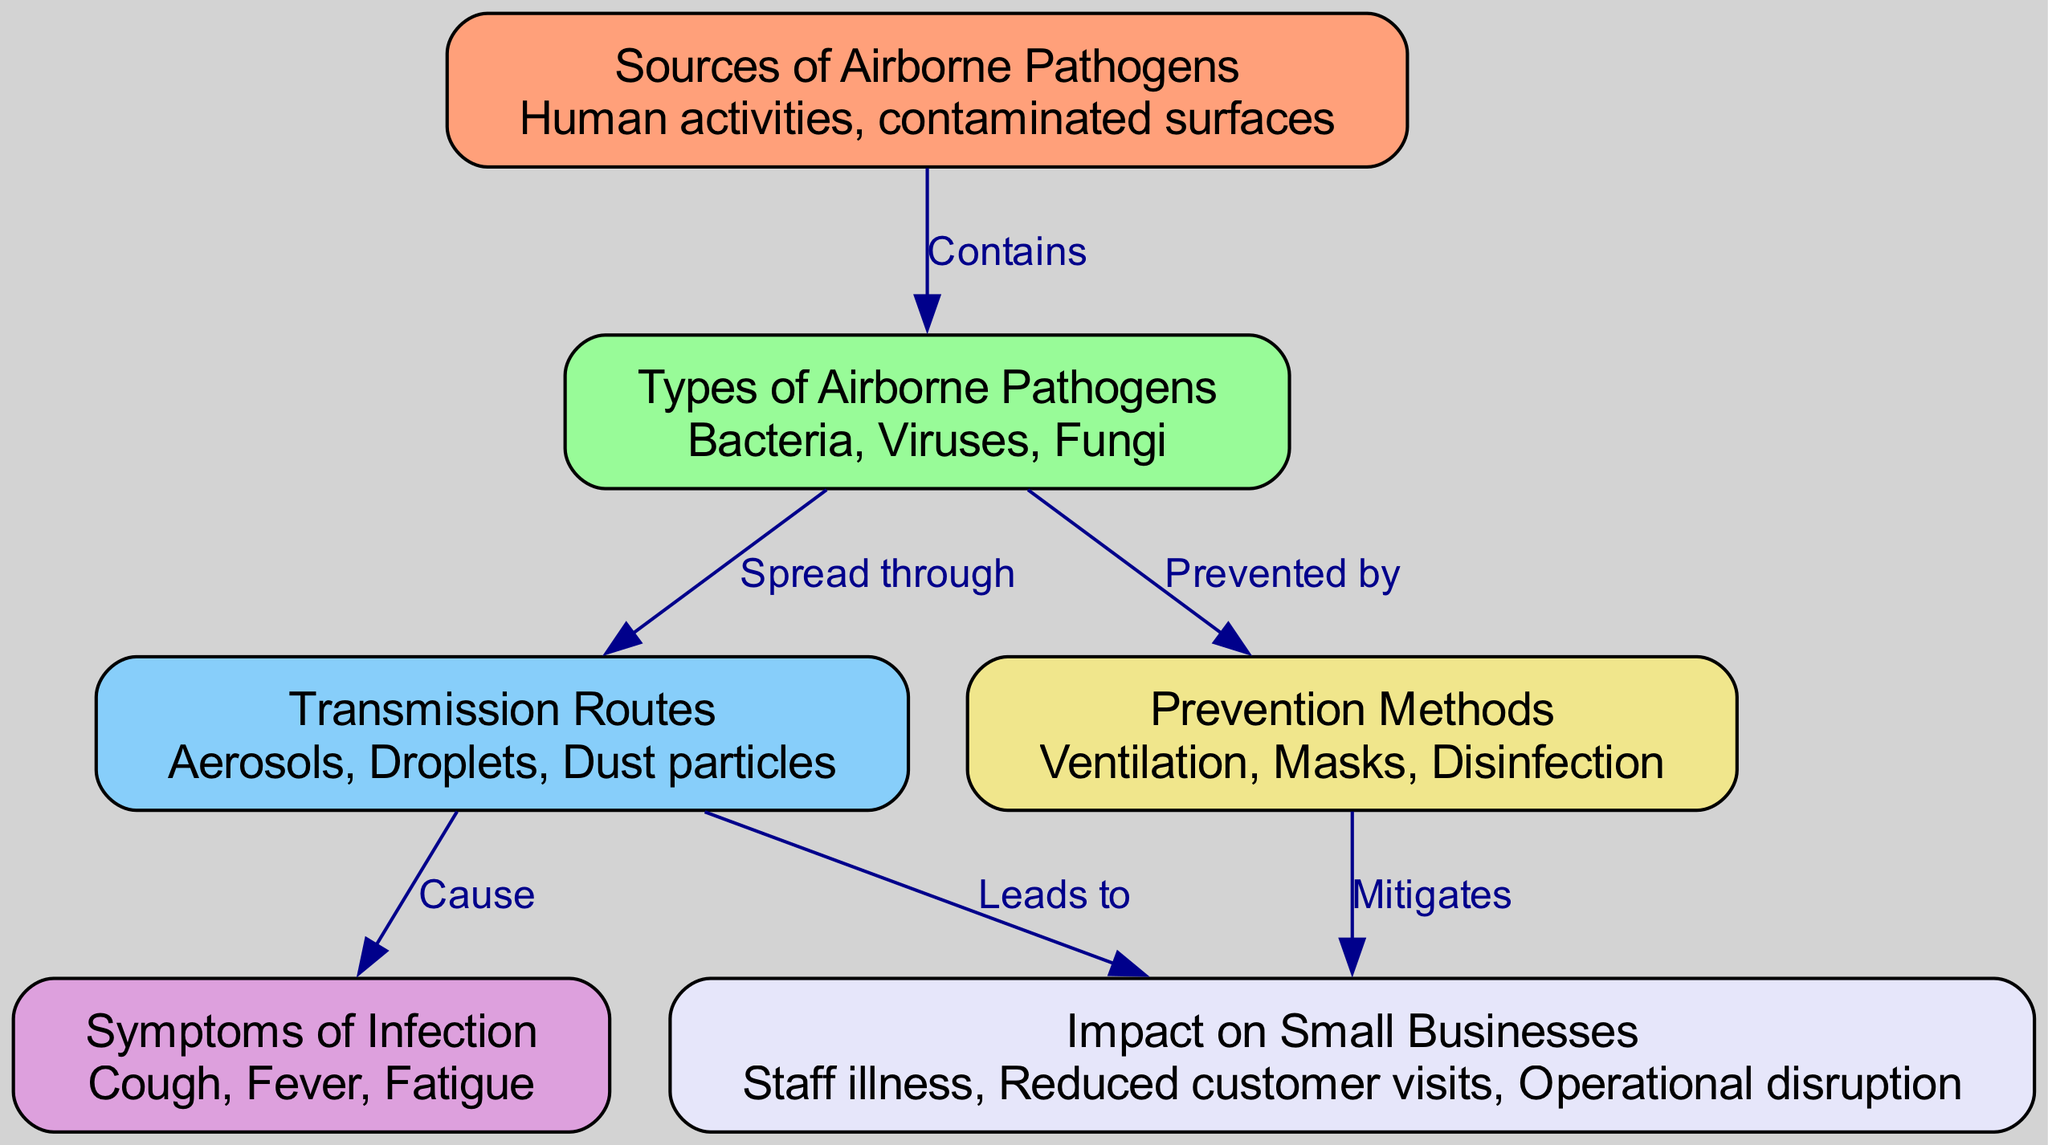What are the sources of airborne pathogens? The diagram lists "Human activities" and "contaminated surfaces" as the sources of airborne pathogens in the node labeled "Sources of Airborne Pathogens."
Answer: Human activities, contaminated surfaces How many types of airborne pathogens are mentioned? The node labeled "Types of Airborne Pathogens" lists "Bacteria," "Viruses," and "Fungi." Therefore, there are three types mentioned in the diagram.
Answer: 3 What is a symptom of infection caused by airborne pathogens? The diagram presents three symptoms in the node labeled "Symptoms of Infection," including "Cough," "Fever," and "Fatigue." Therefore, any one of these can be mentioned as a symptom.
Answer: Cough What leads to reduced customer visits in small businesses? The diagram illustrates that "Transmission Routes" lead to "Impact on Small Businesses," which specifies "Reduced customer visits." Hence, the transmission routes are the direct cause of this impact.
Answer: Transmission Routes Which prevention method mitigates the impact on small businesses? The node labeled "Prevention Methods" states that they "Mitigate" the "Impact on Small Businesses." This implies that implementing any of these prevention methods, such as "Ventilation," "Masks," or "Disinfection," helps to lessen the negative effects.
Answer: Prevention Methods What is the relationship between types of airborne pathogens and their prevention methods? The diagram shows an edge from "Types of Airborne Pathogens" to "Prevention Methods," indicating that the prevention methods are designed to counteract or prevent these types of pathogens. Therefore, their relationship is one of prevention from pathogens.
Answer: Prevented by What are the main symptoms associated with airborne pathogen infections? The "Symptoms of Infection" node details the main symptoms, which include "Cough," "Fever," and "Fatigue." These represent the typical responses of the body to infections caused by airborne pathogens.
Answer: Cough, Fever, Fatigue What is described as caused by aerosol transmission routes? The diagram segments the "Transmission Routes" leading to "Symptoms of Infection." Since aerosols are one of the transmission methods listed, they cause the symptoms mentioned.
Answer: Symptoms of Infection How does improved ventilation affect small businesses? The diagram shows that improved "Ventilation" is a prevention method which "Mitigates" the "Impact on Small Businesses," including possible staff illness and reduced operations. Thus, better ventilation decreases these impacts.
Answer: Mitigates 